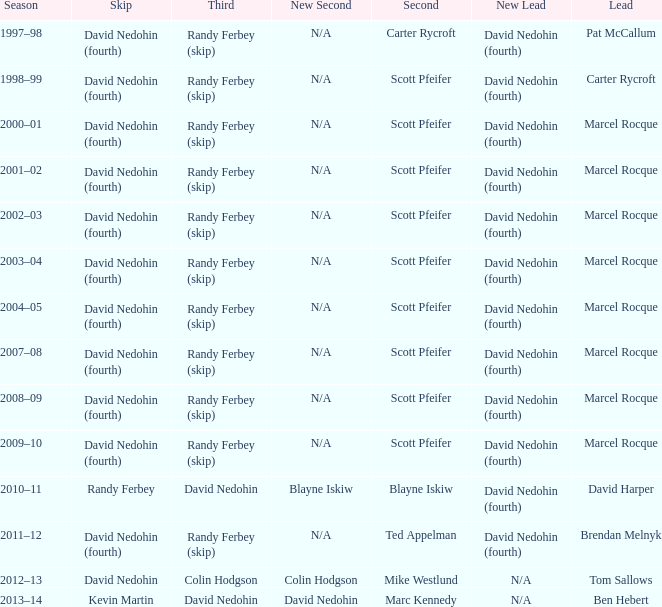Which Second has a Lead of ben hebert? Marc Kennedy. 